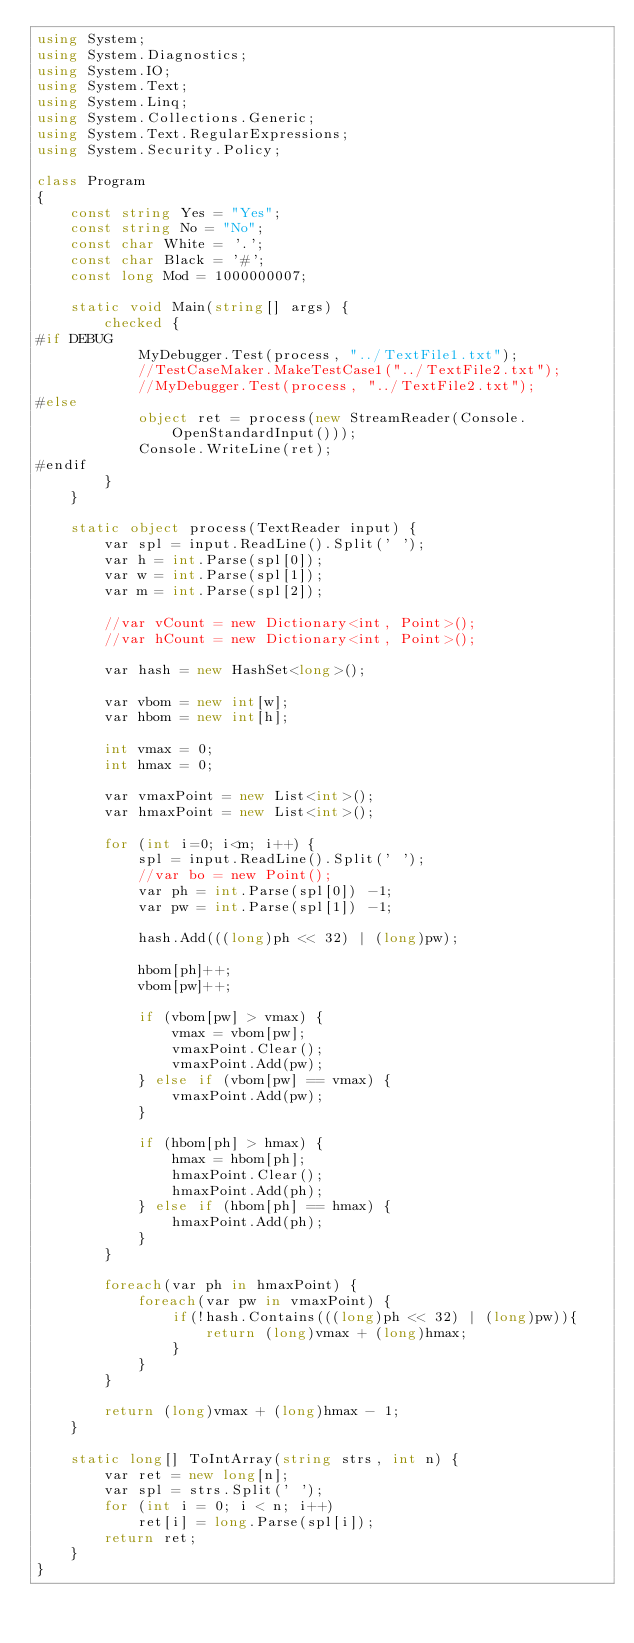Convert code to text. <code><loc_0><loc_0><loc_500><loc_500><_C#_>using System;
using System.Diagnostics;
using System.IO;
using System.Text;
using System.Linq;
using System.Collections.Generic;
using System.Text.RegularExpressions;
using System.Security.Policy;

class Program
{
    const string Yes = "Yes";
    const string No = "No";
    const char White = '.';
    const char Black = '#';
    const long Mod = 1000000007;

    static void Main(string[] args) {
        checked {
#if DEBUG
            MyDebugger.Test(process, "../TextFile1.txt");
            //TestCaseMaker.MakeTestCase1("../TextFile2.txt");
            //MyDebugger.Test(process, "../TextFile2.txt");
#else
            object ret = process(new StreamReader(Console.OpenStandardInput()));
            Console.WriteLine(ret);
#endif
        }
    }

    static object process(TextReader input) {
        var spl = input.ReadLine().Split(' ');
        var h = int.Parse(spl[0]);
        var w = int.Parse(spl[1]);
        var m = int.Parse(spl[2]);

        //var vCount = new Dictionary<int, Point>();
        //var hCount = new Dictionary<int, Point>();

        var hash = new HashSet<long>();

        var vbom = new int[w];
        var hbom = new int[h];

        int vmax = 0;
        int hmax = 0;

        var vmaxPoint = new List<int>();
        var hmaxPoint = new List<int>();

        for (int i=0; i<m; i++) {
            spl = input.ReadLine().Split(' ');
            //var bo = new Point();
            var ph = int.Parse(spl[0]) -1;
            var pw = int.Parse(spl[1]) -1;

            hash.Add(((long)ph << 32) | (long)pw);

            hbom[ph]++;
            vbom[pw]++;

            if (vbom[pw] > vmax) {
                vmax = vbom[pw];
                vmaxPoint.Clear();
                vmaxPoint.Add(pw);
            } else if (vbom[pw] == vmax) {
                vmaxPoint.Add(pw);
            }

            if (hbom[ph] > hmax) {
                hmax = hbom[ph];
                hmaxPoint.Clear();
                hmaxPoint.Add(ph);
            } else if (hbom[ph] == hmax) {
                hmaxPoint.Add(ph);
            }
        }

        foreach(var ph in hmaxPoint) {
            foreach(var pw in vmaxPoint) {
                if(!hash.Contains(((long)ph << 32) | (long)pw)){
                    return (long)vmax + (long)hmax;
                }
            }
        }

        return (long)vmax + (long)hmax - 1;
    }

    static long[] ToIntArray(string strs, int n) {
        var ret = new long[n];
        var spl = strs.Split(' ');
        for (int i = 0; i < n; i++)
            ret[i] = long.Parse(spl[i]);
        return ret;
    }
}
</code> 